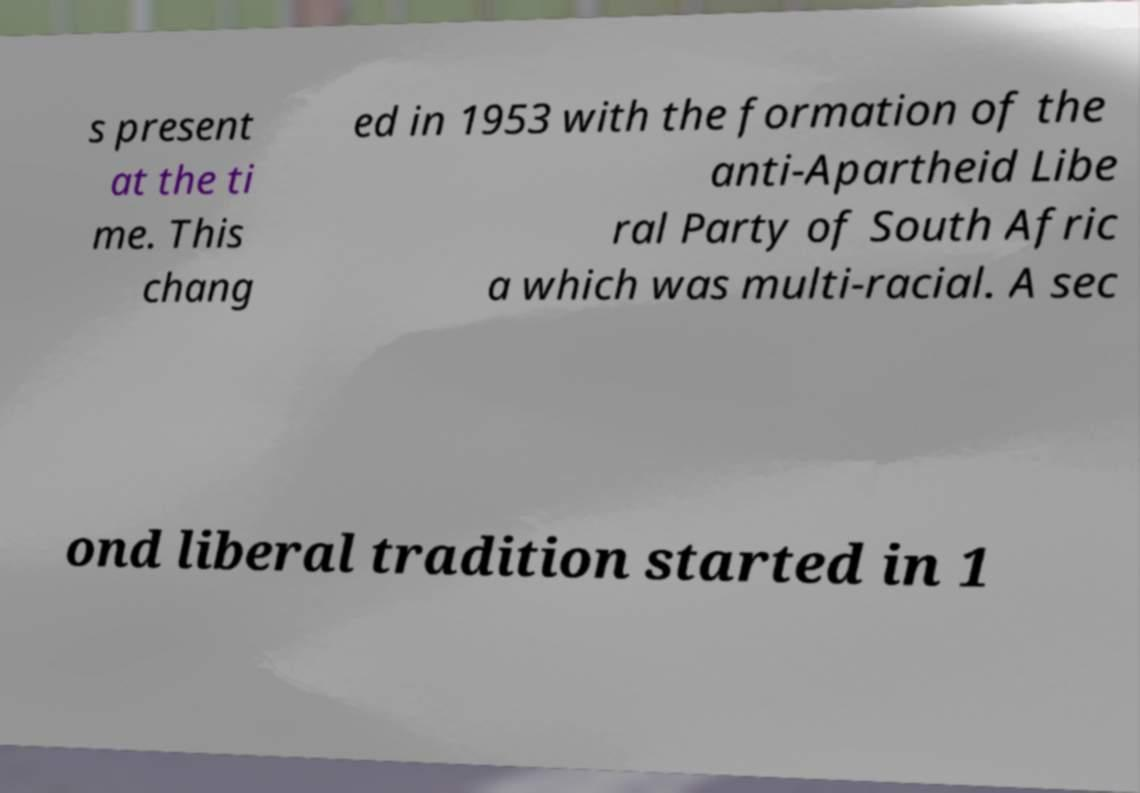There's text embedded in this image that I need extracted. Can you transcribe it verbatim? s present at the ti me. This chang ed in 1953 with the formation of the anti-Apartheid Libe ral Party of South Afric a which was multi-racial. A sec ond liberal tradition started in 1 